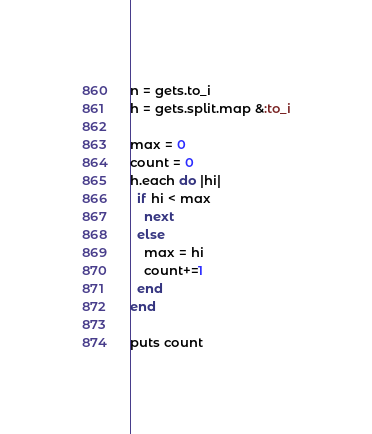<code> <loc_0><loc_0><loc_500><loc_500><_Ruby_>n = gets.to_i
h = gets.split.map &:to_i

max = 0
count = 0
h.each do |hi|
  if hi < max
    next
  else
    max = hi
    count+=1
  end
end

puts count
</code> 